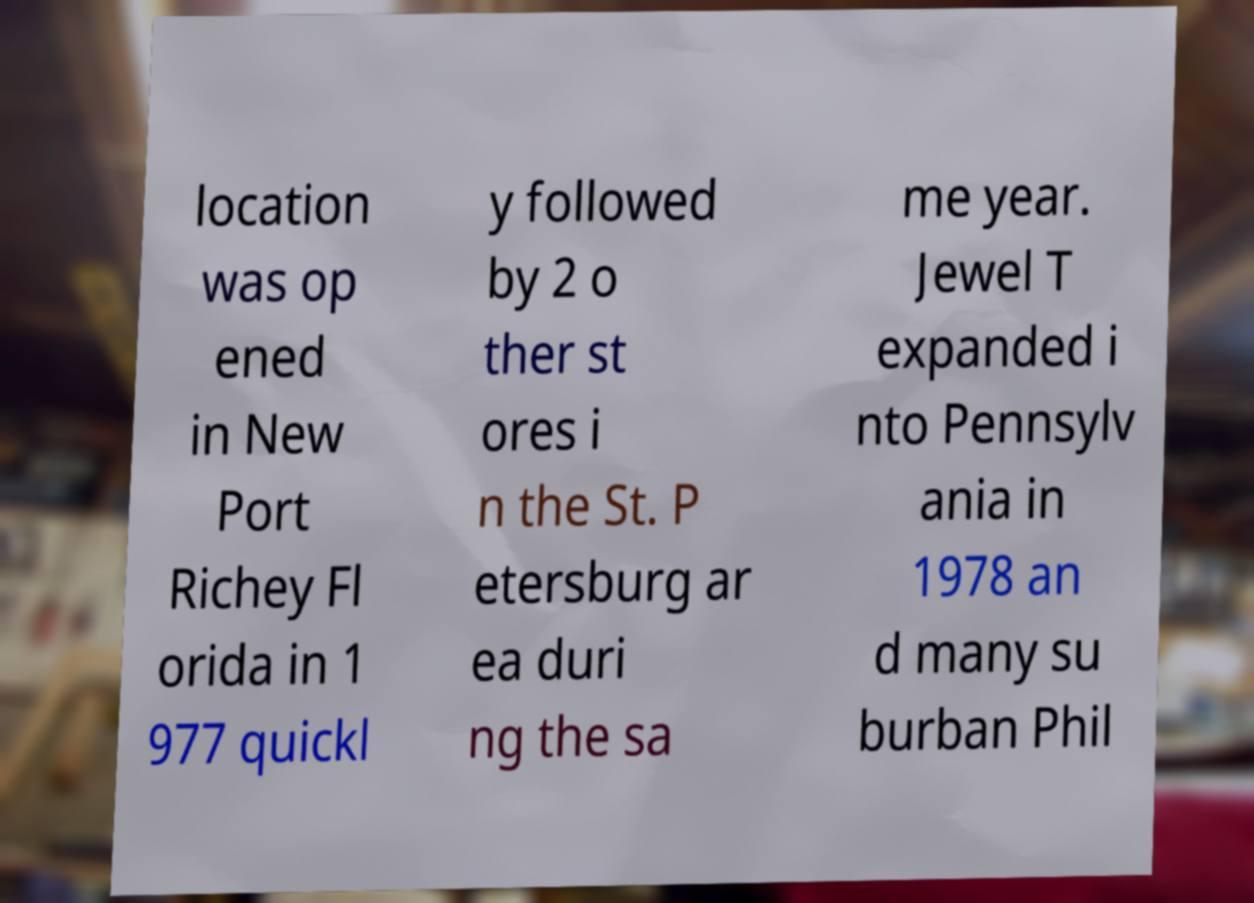Could you extract and type out the text from this image? location was op ened in New Port Richey Fl orida in 1 977 quickl y followed by 2 o ther st ores i n the St. P etersburg ar ea duri ng the sa me year. Jewel T expanded i nto Pennsylv ania in 1978 an d many su burban Phil 